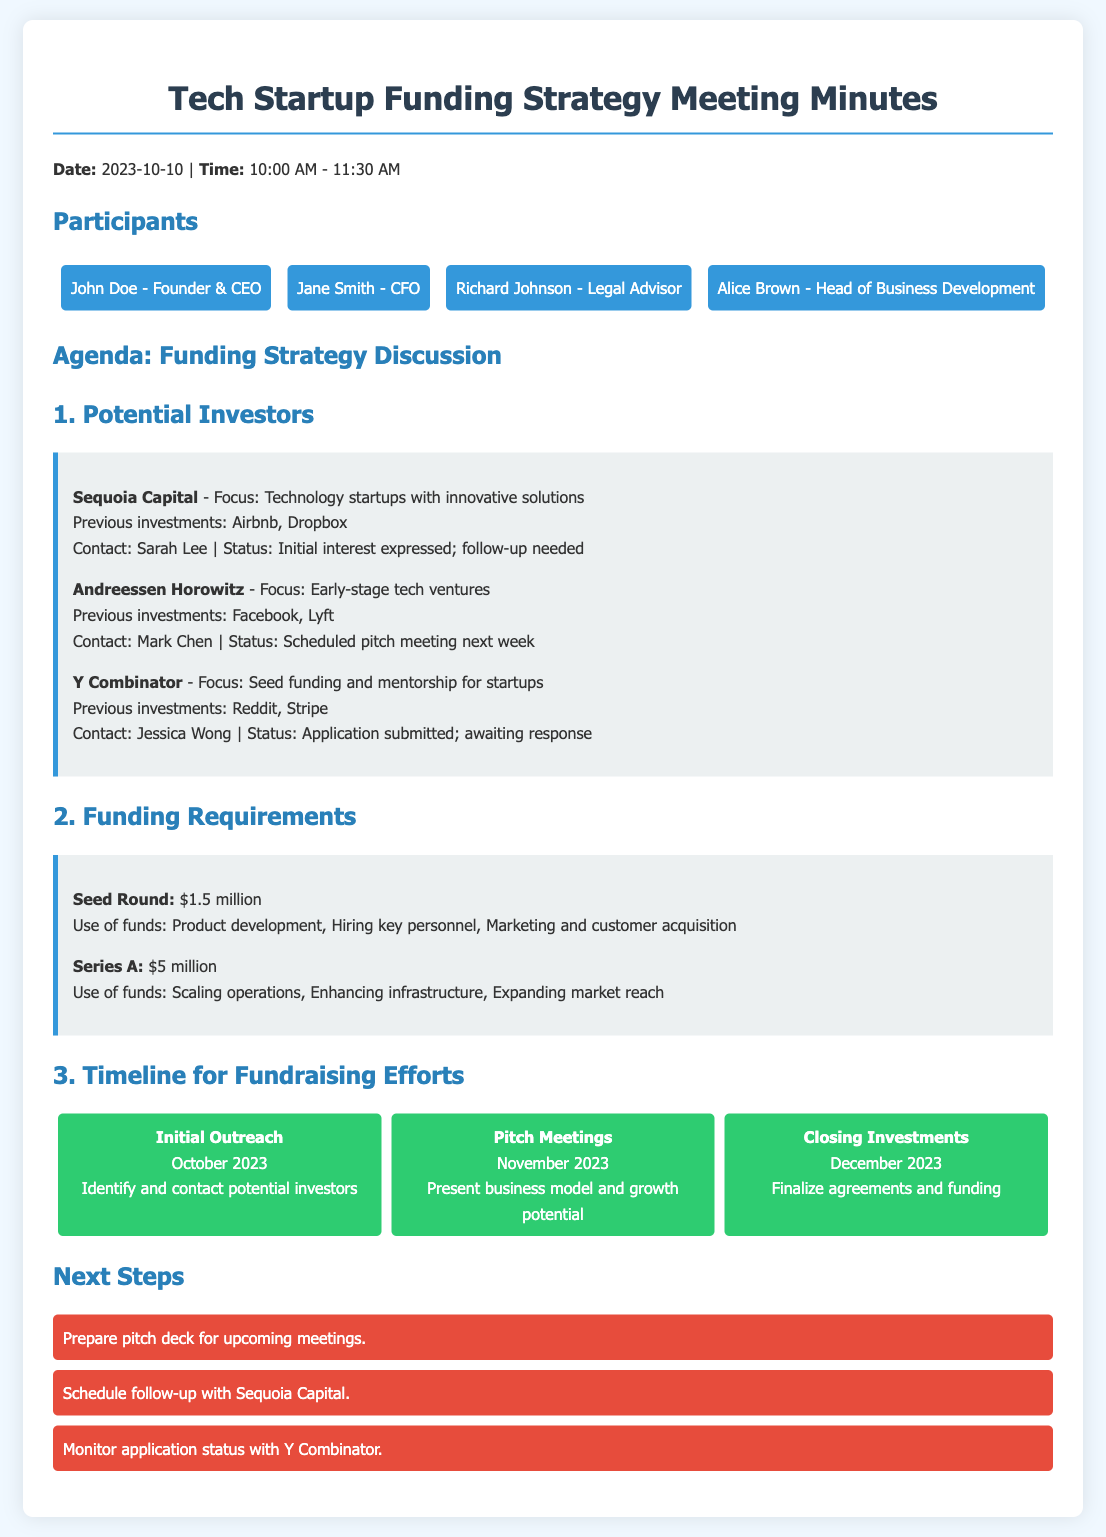What is the date of the meeting? The date is specified in the meeting minutes.
Answer: 2023-10-10 Who is the contact person for Sequoia Capital? The contact person is mentioned under the potential investors section.
Answer: Sarah Lee What is the funding requirement for the Seed Round? The funding requirement details are listed under funding requirements.
Answer: $1.5 million When is the scheduled pitch meeting with Andreessen Horowitz? The timeline information mentions when the pitch meeting will occur.
Answer: Next week What is the main purpose of the funds in the Series A round? The use of funds is specified for Series A under funding requirements.
Answer: Scaling operations What is the status of the application with Y Combinator? The status of the application is noted under potential investors.
Answer: Awaiting response When will the closing of investments occur? This information is part of the timeline for fundraising efforts.
Answer: December 2023 What needs to be monitored according to the next steps? The next steps section lists specific tasks to be completed.
Answer: Application status with Y Combinator 